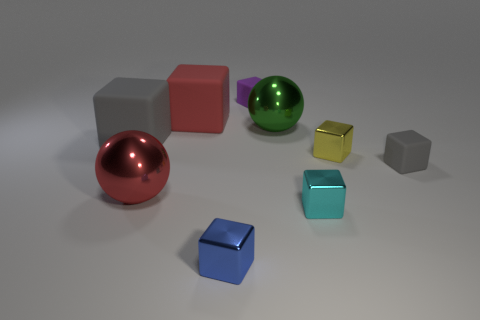How many other things are the same shape as the blue shiny object?
Ensure brevity in your answer.  6. There is a cyan metal thing; does it have the same shape as the small rubber thing in front of the purple rubber thing?
Offer a terse response. Yes. What number of metal blocks are to the right of the blue metallic block?
Provide a short and direct response. 2. Is there anything else that has the same material as the cyan object?
Keep it short and to the point. Yes. Does the gray matte thing that is on the left side of the blue block have the same shape as the red shiny object?
Offer a terse response. No. What color is the tiny rubber object to the left of the large green shiny sphere?
Your answer should be compact. Purple. What is the shape of the large object that is made of the same material as the big red sphere?
Offer a very short reply. Sphere. Is the number of yellow metal blocks to the left of the red ball greater than the number of tiny purple objects that are right of the small yellow block?
Keep it short and to the point. No. What number of blue things are the same size as the cyan cube?
Your answer should be very brief. 1. Is the number of spheres in front of the red shiny object less than the number of blue things to the right of the green object?
Your answer should be compact. No. 